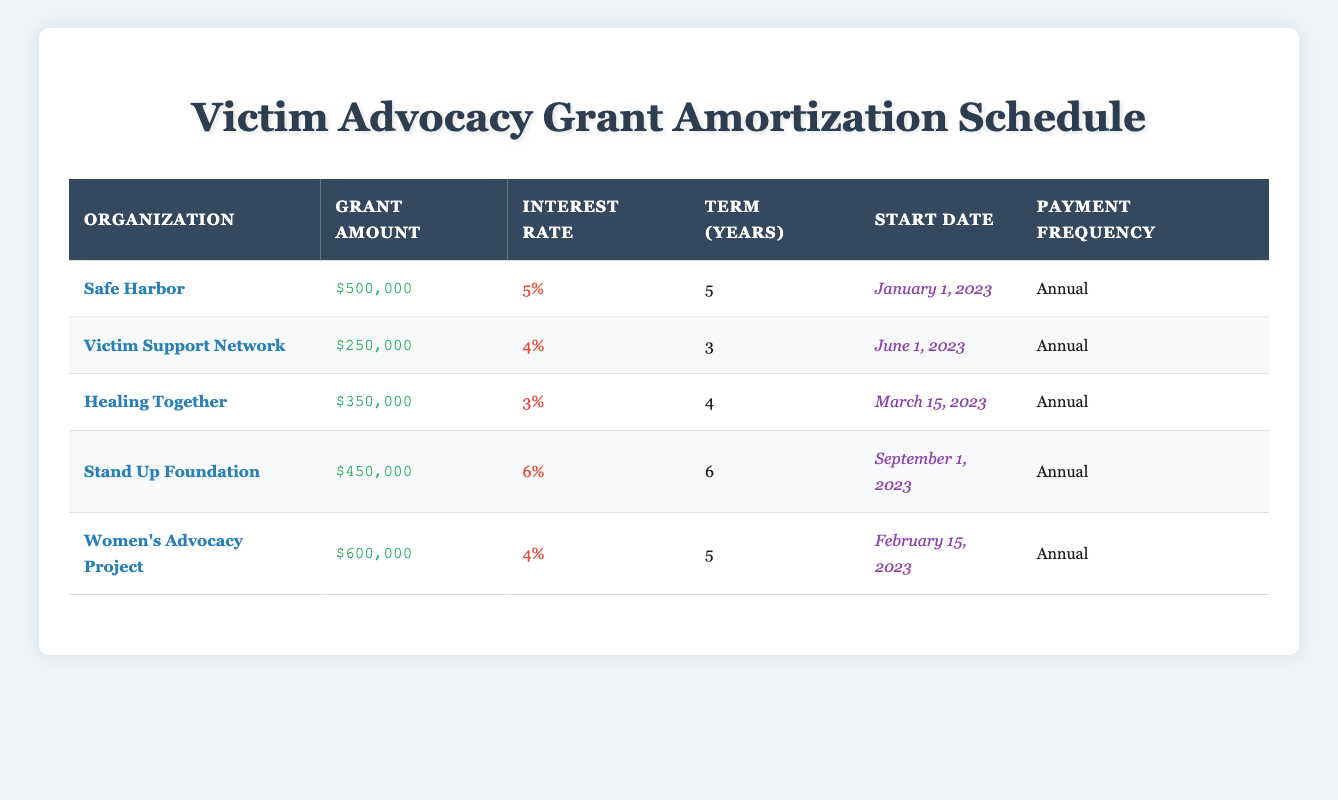What is the grant amount awarded to Safe Harbor? The table states that Safe Harbor has been awarded a grant amount of $500,000.
Answer: $500,000 What is the interest rate for the Healing Together organization? Referring to the table, Healing Together has an interest rate of 3%.
Answer: 3% Which organization has the longest loan term? Stand Up Foundation has the longest term of 6 years compared to all other organizations listed.
Answer: Stand Up Foundation What is the total grant amount awarded to Women's Advocacy Project and Safe Harbor combined? The grant amount for Women's Advocacy Project is $600,000 and for Safe Harbor is $500,000. Adding these values gives $600,000 + $500,000 = $1,100,000.
Answer: $1,100,000 Does the Victim Support Network have a lower interest rate than Safe Harbor? Victim Support Network has an interest rate of 4%, while Safe Harbor's interest rate is 5%. Since 4% is less than 5%, the statement is true.
Answer: Yes What is the average grant amount awarded to these organizations? First, sum the grant amounts: $500,000 + $250,000 + $350,000 + $450,000 + $600,000 = $2,150,000. Since there are 5 organizations, the average is $2,150,000 / 5 = $430,000.
Answer: $430,000 Which organization received the smallest grant amount? Comparing all grant amounts, the smallest amount is for Victim Support Network at $250,000.
Answer: Victim Support Network Is there any organization with an interest rate of 6%? Looking at the table, the Stand Up Foundation is listed with an interest rate of 6%. Therefore, the answer is true.
Answer: Yes How many organizations have an interest rate that is less than 5%? We have Healing Together (3%) and Victim Support Network (4%) with interest rates less than 5%. So, there are 2 organizations fitting this criterion.
Answer: 2 